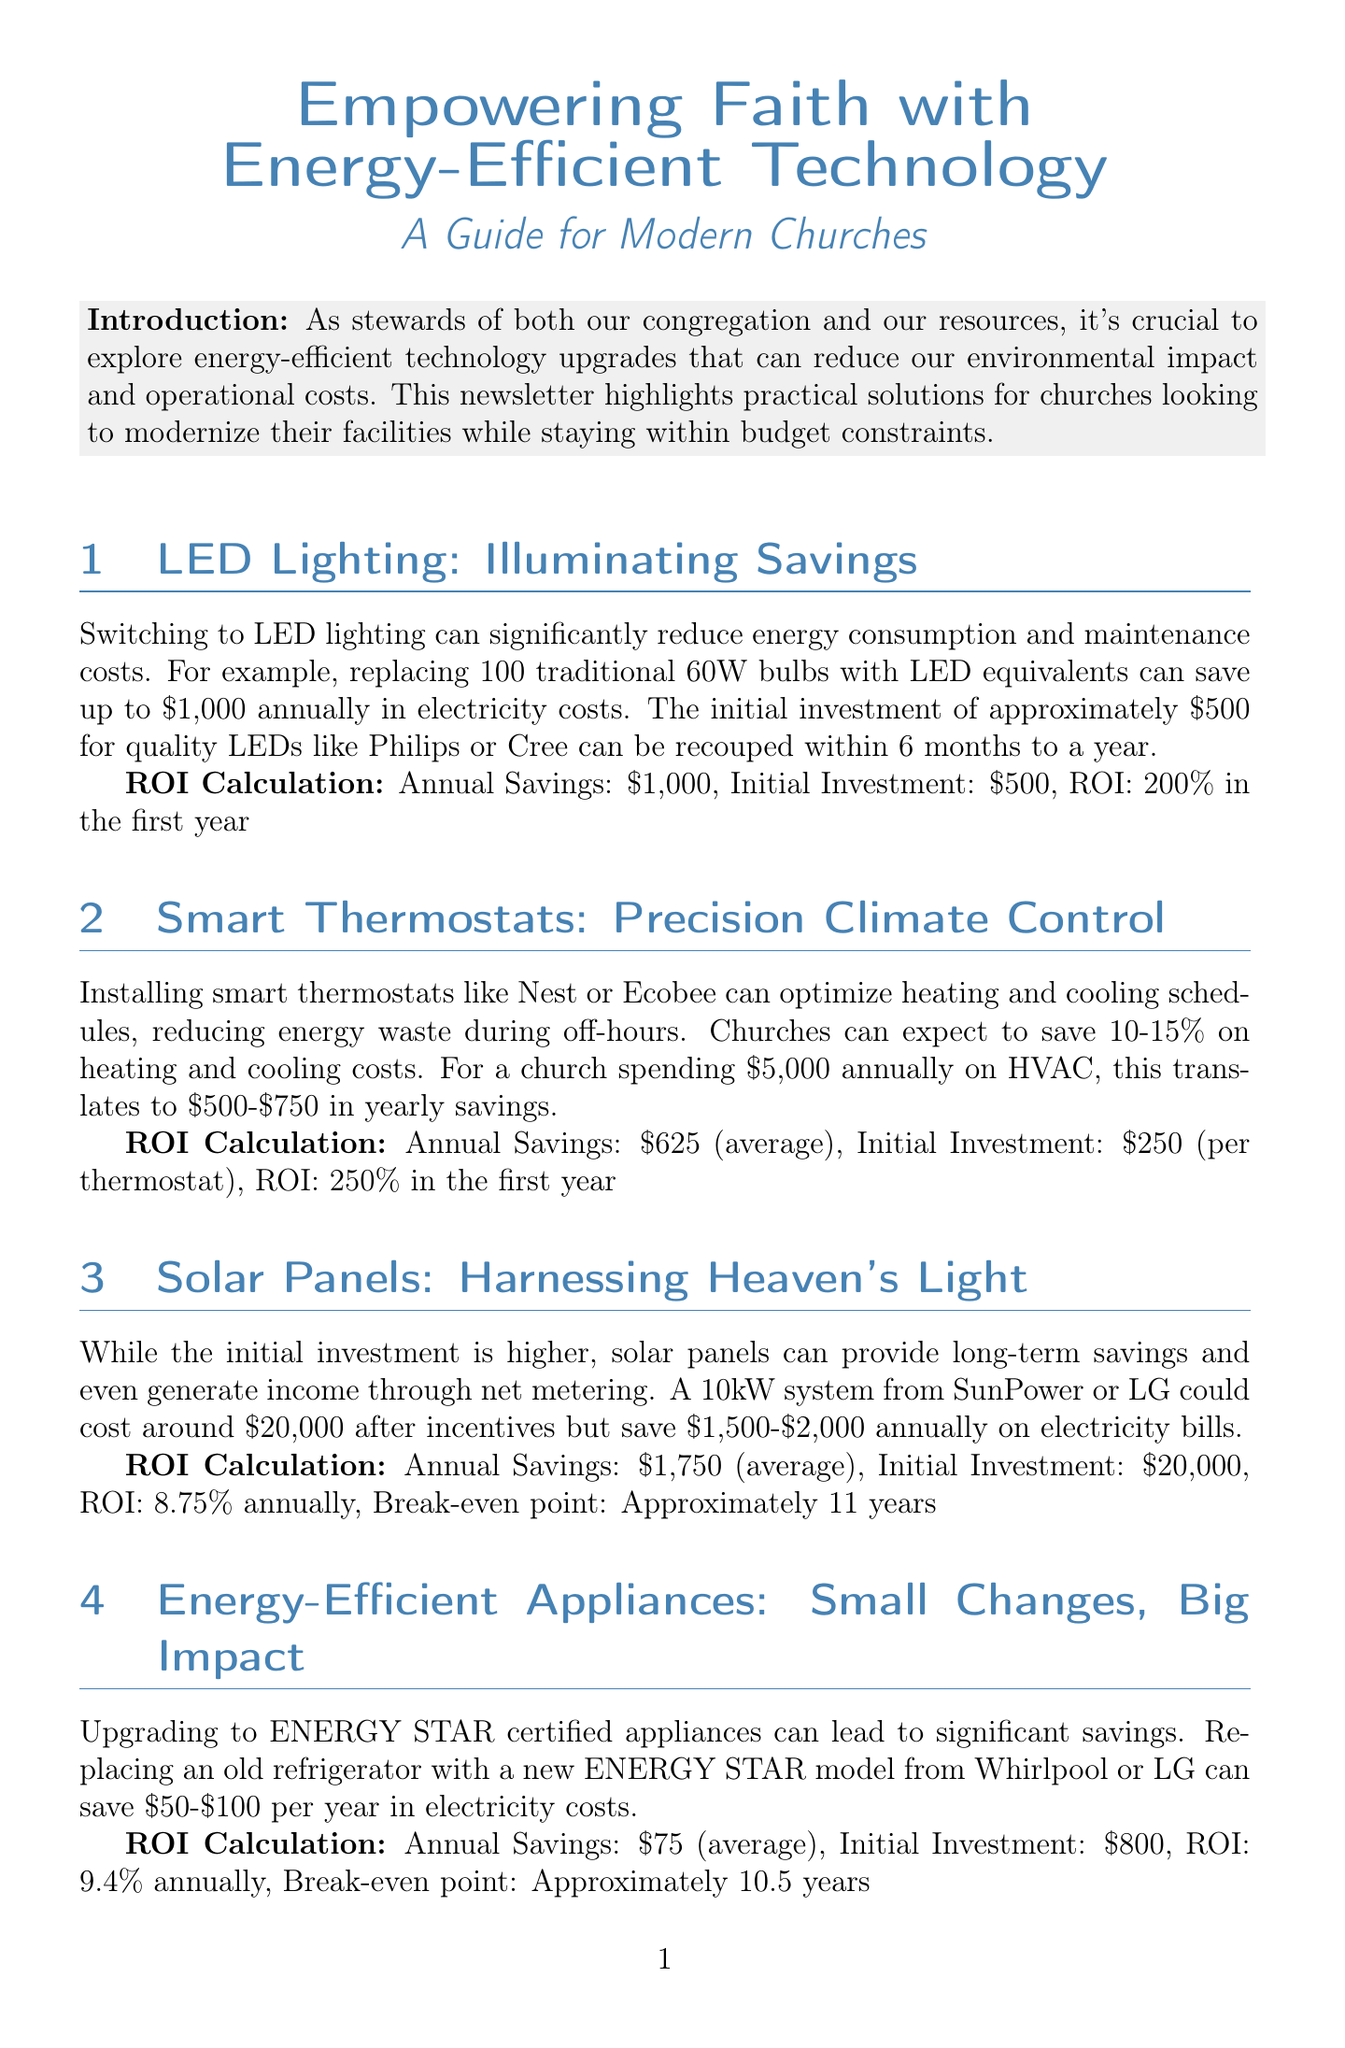what is the newsletter title? The newsletter title is stated at the beginning of the document and is "Empowering Faith with Energy-Efficient Technology: A Guide for Modern Churches."
Answer: Empowering Faith with Energy-Efficient Technology: A Guide for Modern Churches what is the initial investment for LED lighting? The content specifically mentions the initial investment required for LED lighting upgrades.
Answer: $500 how much can churches save annually by switching to smart thermostats? The document provides an average savings figure for smart thermostats in the HVAC section.
Answer: $625 what is the ROI for solar panels? The return on investment for solar panels is calculated in the document and is specified clearly.
Answer: 8.75% annually what type of fixtures can help conserve water? The document lists specific types of fixtures under the water-saving section that can conserve water.
Answer: Low-flow faucets and toilets which brand names are mentioned for ENERGY STAR appliances? The document identifies specific brand names under the energy-efficient appliances section.
Answer: Whirlpool or LG how long is the break-even point for upgrading to water-saving fixtures? The break-even point is mentioned in the section discussing water-saving fixtures investment returns.
Answer: Approximately 2 years what percentage savings is expected from smart thermostats? The content outlines the expected savings percentage from smart thermostat installations.
Answer: 10-15% what format is used for the document? The document is formatted specifically as a newsletter for church technology upgrades.
Answer: Newsletter 